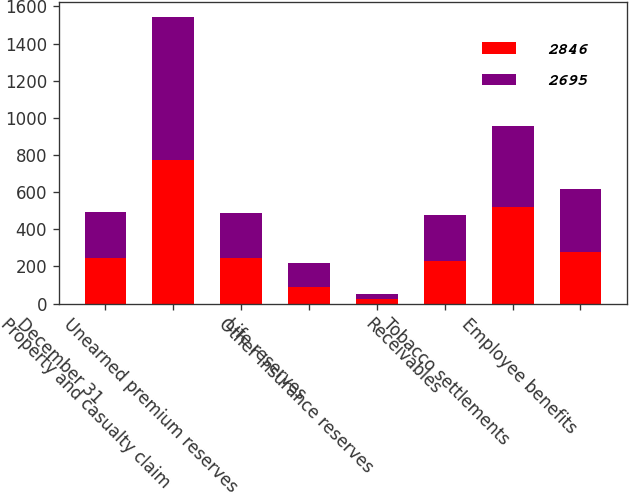Convert chart. <chart><loc_0><loc_0><loc_500><loc_500><stacked_bar_chart><ecel><fcel>December 31<fcel>Property and casualty claim<fcel>Unearned premium reserves<fcel>Life reserves<fcel>Other insurance reserves<fcel>Receivables<fcel>Tobacco settlements<fcel>Employee benefits<nl><fcel>2846<fcel>246.5<fcel>771<fcel>243<fcel>89<fcel>24<fcel>231<fcel>520<fcel>277<nl><fcel>2695<fcel>246.5<fcel>775<fcel>245<fcel>132<fcel>26<fcel>248<fcel>436<fcel>339<nl></chart> 